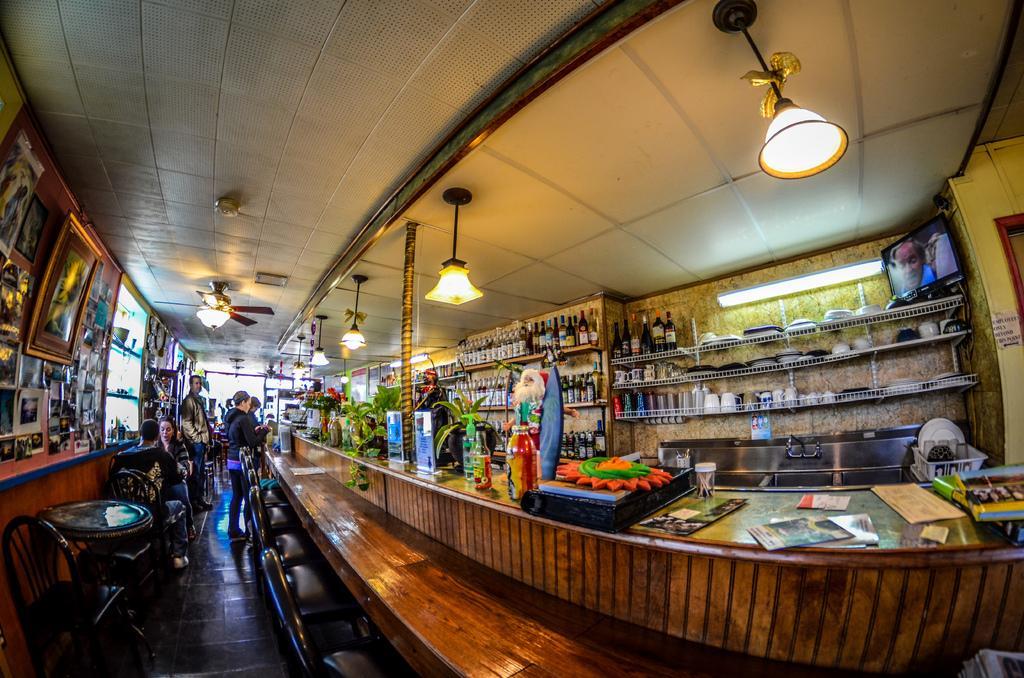Can you describe this image briefly? It is a store. on the left side there are some photo frames, tables and chairs. Some people are standing and sitting over there. There are fan lights on the ceiling. On the right side there is a table. On the table there are books, bottles, plants, pots and many items are kept. Behind that there are some racks on the racks there are bottles. There is a TV on the wall. 